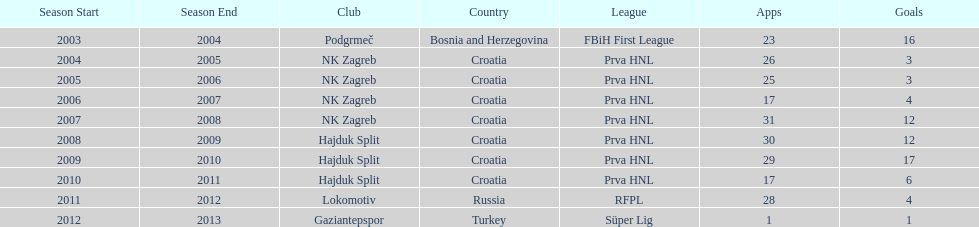What were the names of each club where more than 15 goals were scored in a single season? Podgrmeč, Hajduk Split. 